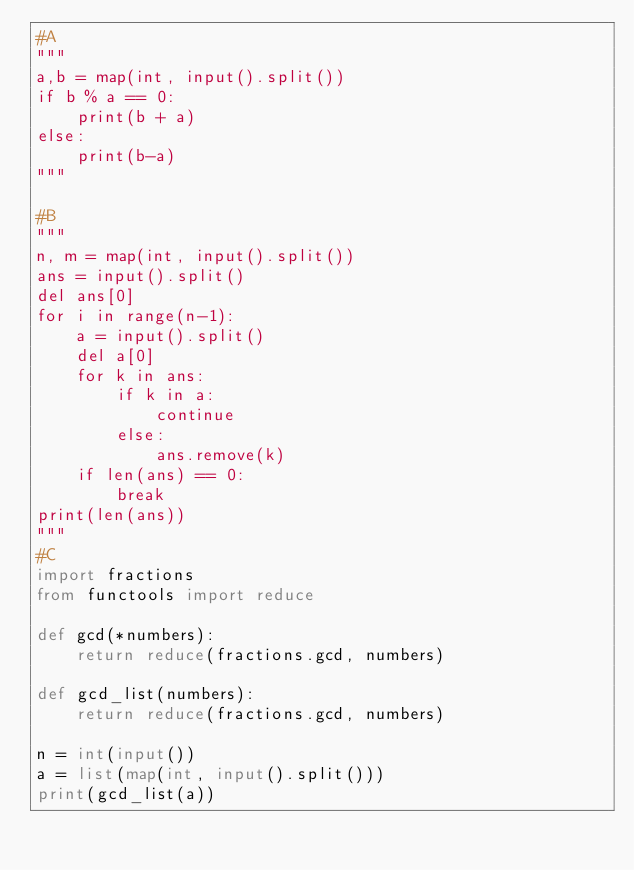Convert code to text. <code><loc_0><loc_0><loc_500><loc_500><_Python_>#A
"""
a,b = map(int, input().split())
if b % a == 0:
    print(b + a)
else:
    print(b-a)
"""

#B
"""
n, m = map(int, input().split())
ans = input().split()
del ans[0]
for i in range(n-1):
    a = input().split()
    del a[0]
    for k in ans:
        if k in a:
            continue
        else:
            ans.remove(k)
    if len(ans) == 0:
        break
print(len(ans))
"""
#C
import fractions
from functools import reduce

def gcd(*numbers):
    return reduce(fractions.gcd, numbers)

def gcd_list(numbers):
    return reduce(fractions.gcd, numbers)

n = int(input())
a = list(map(int, input().split()))
print(gcd_list(a))</code> 